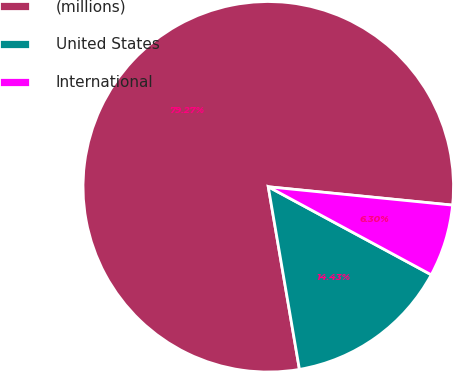Convert chart. <chart><loc_0><loc_0><loc_500><loc_500><pie_chart><fcel>(millions)<fcel>United States<fcel>International<nl><fcel>79.27%<fcel>14.43%<fcel>6.3%<nl></chart> 